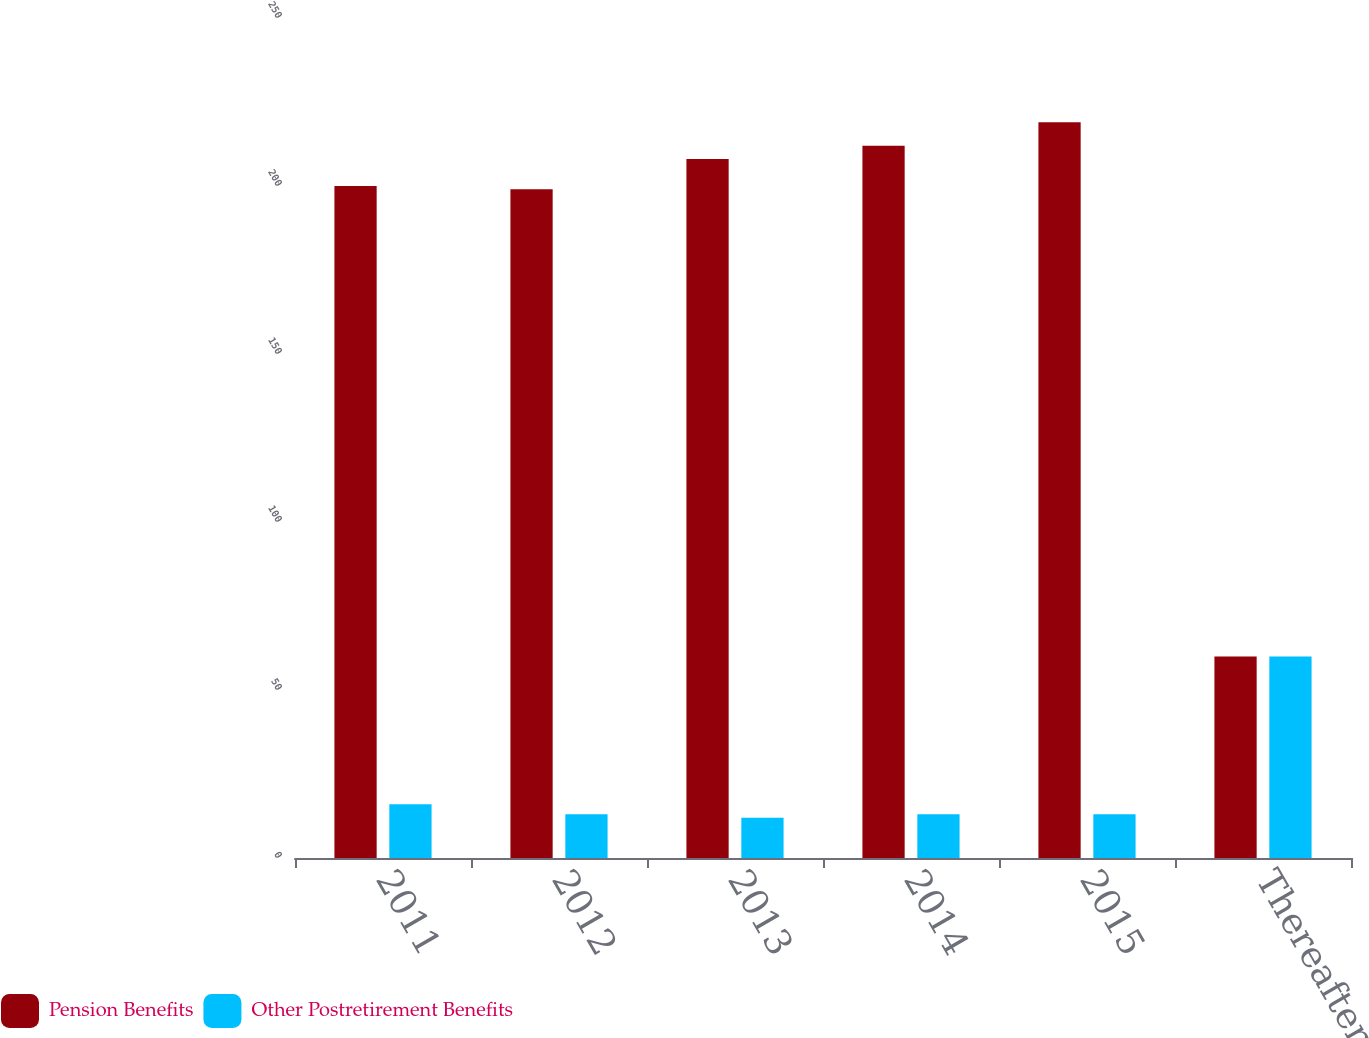Convert chart to OTSL. <chart><loc_0><loc_0><loc_500><loc_500><stacked_bar_chart><ecel><fcel>2011<fcel>2012<fcel>2013<fcel>2014<fcel>2015<fcel>Thereafter<nl><fcel>Pension Benefits<fcel>200<fcel>199<fcel>208<fcel>212<fcel>219<fcel>60<nl><fcel>Other Postretirement Benefits<fcel>16<fcel>13<fcel>12<fcel>13<fcel>13<fcel>60<nl></chart> 